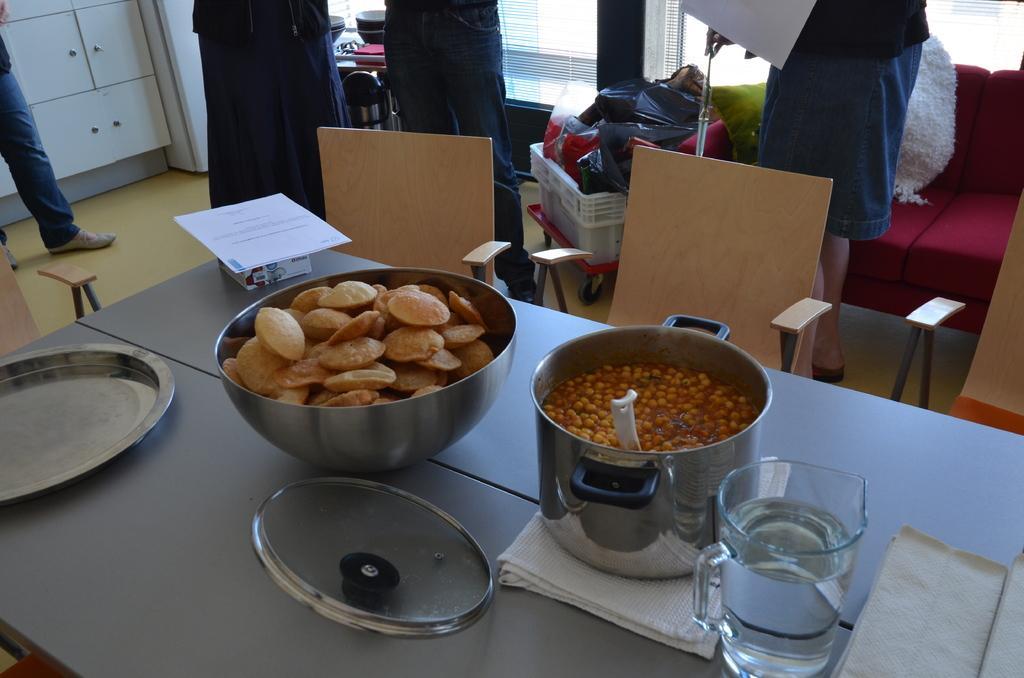In one or two sentences, can you explain what this image depicts? In the foreground of the picture there are tables, jar, clothes, food items, paper, chairs and other objects. In the picture there are people, baskets, covers, couch, bowls, closet and other objects. In the background windows and window blinds. 